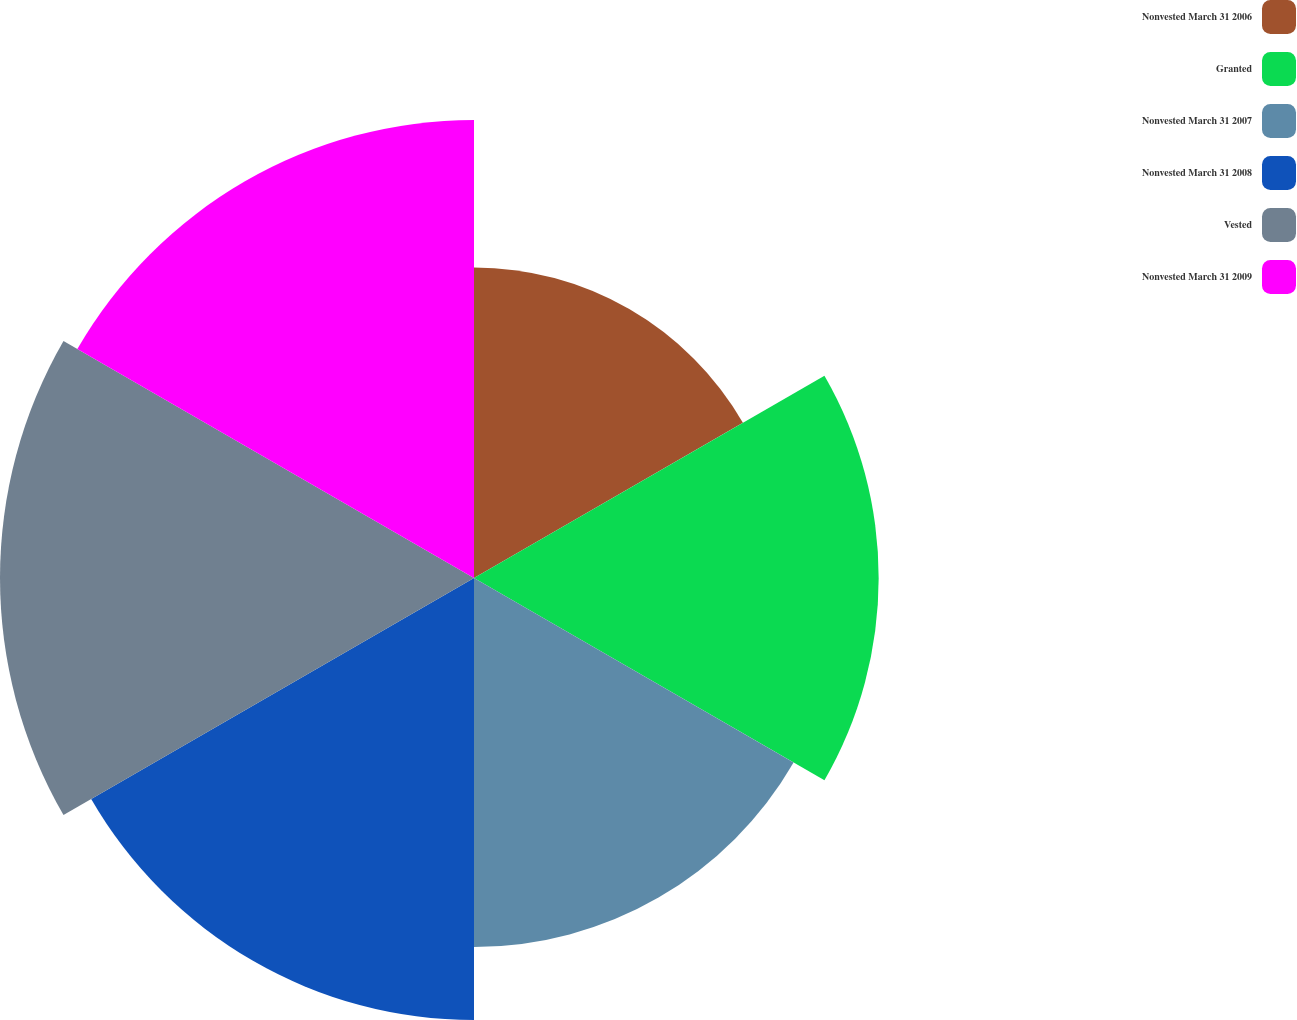<chart> <loc_0><loc_0><loc_500><loc_500><pie_chart><fcel>Nonvested March 31 2006<fcel>Granted<fcel>Nonvested March 31 2007<fcel>Nonvested March 31 2008<fcel>Vested<fcel>Nonvested March 31 2009<nl><fcel>12.63%<fcel>16.46%<fcel>15.01%<fcel>17.98%<fcel>19.28%<fcel>18.63%<nl></chart> 